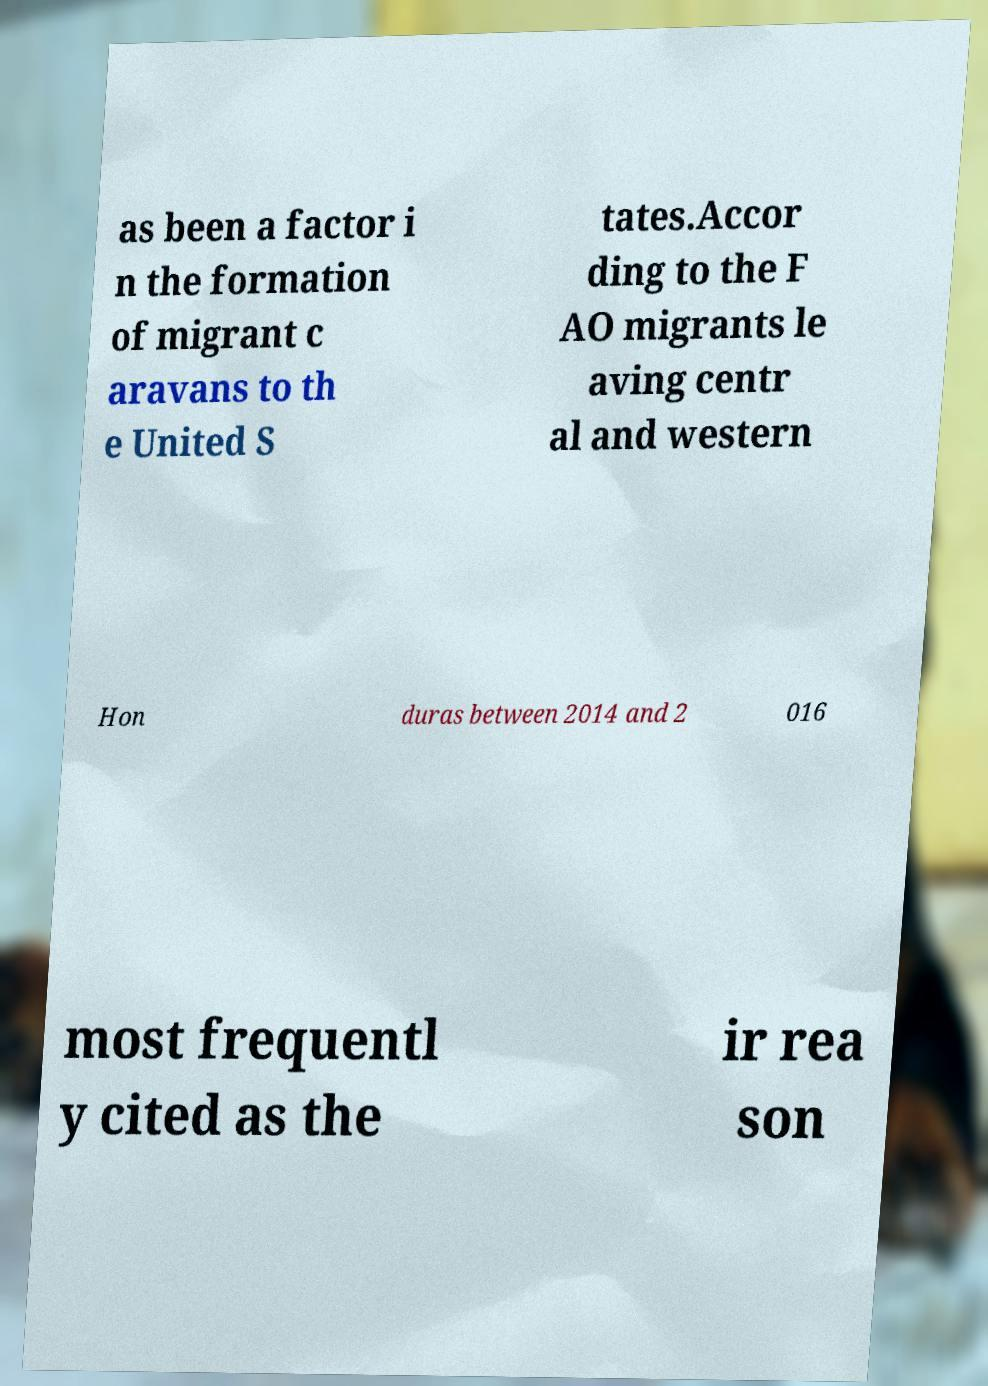Could you assist in decoding the text presented in this image and type it out clearly? as been a factor i n the formation of migrant c aravans to th e United S tates.Accor ding to the F AO migrants le aving centr al and western Hon duras between 2014 and 2 016 most frequentl y cited as the ir rea son 